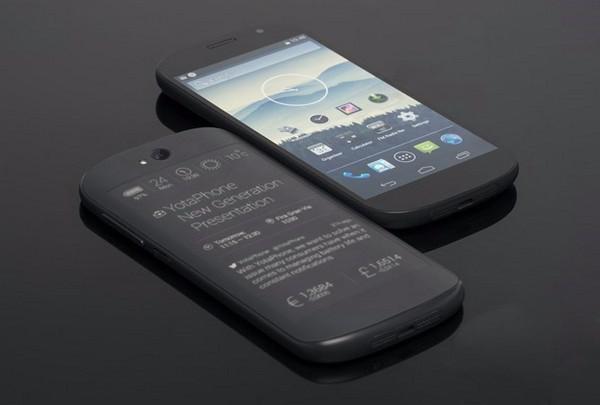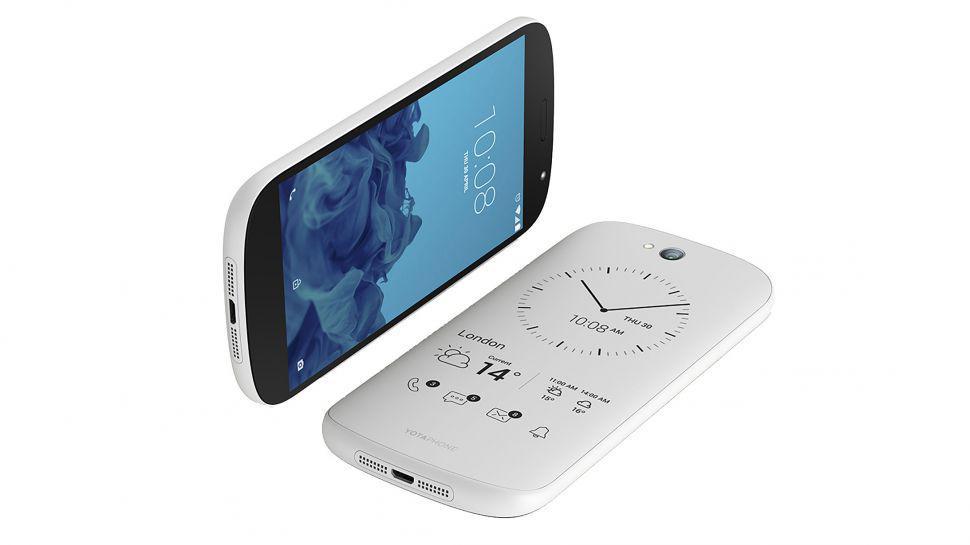The first image is the image on the left, the second image is the image on the right. Evaluate the accuracy of this statement regarding the images: "One of the phones has physical keys for typing.". Is it true? Answer yes or no. No. The first image is the image on the left, the second image is the image on the right. For the images shown, is this caption "The back of a phone is visible." true? Answer yes or no. Yes. 